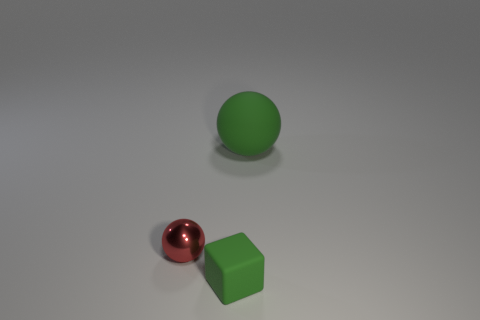What is the material of the green thing in front of the green rubber ball?
Give a very brief answer. Rubber. What size is the matte object that is the same color as the rubber cube?
Make the answer very short. Large. Are there any blocks of the same size as the red shiny ball?
Make the answer very short. Yes. Do the tiny green matte thing and the matte object that is behind the red thing have the same shape?
Keep it short and to the point. No. There is a green rubber object that is in front of the large object; does it have the same size as the ball to the left of the big thing?
Provide a succinct answer. Yes. What number of other objects are the same shape as the shiny object?
Offer a very short reply. 1. There is a object that is on the left side of the green thing in front of the large sphere; what is it made of?
Your response must be concise. Metal. How many rubber objects are tiny things or green spheres?
Your answer should be compact. 2. Is there any other thing that is the same material as the green sphere?
Make the answer very short. Yes. There is a tiny red metal object to the left of the rubber cube; are there any big rubber spheres in front of it?
Give a very brief answer. No. 